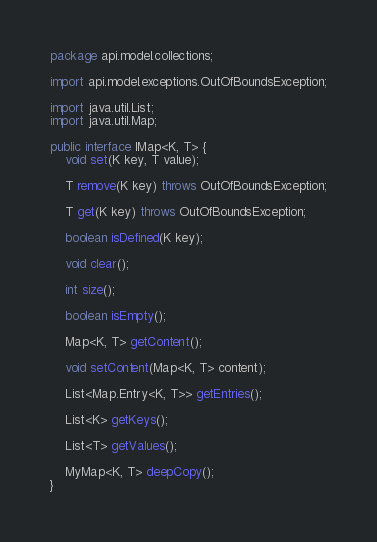Convert code to text. <code><loc_0><loc_0><loc_500><loc_500><_Java_>package api.model.collections;

import api.model.exceptions.OutOfBoundsException;

import java.util.List;
import java.util.Map;

public interface IMap<K, T> {
    void set(K key, T value);

    T remove(K key) throws OutOfBoundsException;

    T get(K key) throws OutOfBoundsException;

    boolean isDefined(K key);

    void clear();

    int size();

    boolean isEmpty();

    Map<K, T> getContent();

    void setContent(Map<K, T> content);

    List<Map.Entry<K, T>> getEntries();

    List<K> getKeys();

    List<T> getValues();

    MyMap<K, T> deepCopy();
}
</code> 